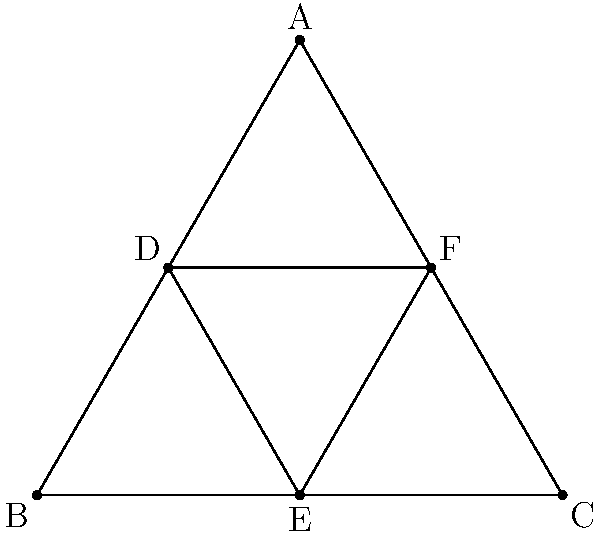In the Star of David shown above, all sides of both triangles are equal. If the angle at vertex A is 60°, calculate the measure of angle ADF. How might this angle's significance in religious symbolism influence your portrayal of divine wisdom in a theatrical script? Let's approach this step-by-step:

1) First, we recognize that the outer triangle ABC is equilateral, as all its sides are equal and the angle at A is given as 60°.

2) In an equilateral triangle, all angles are equal and measure 60°. So, $\angle BAC = \angle ABC = \angle BCA = 60°$.

3) The inner triangle DEF is formed by connecting the midpoints of the sides of the outer triangle. This creates four congruent triangles within ABC.

4) Focus on triangle ADF:
   - AD is half of AB
   - AF is half of AC
   - $\angle BAC = 60°$

5) Therefore, triangle ADF is similar to triangle ABC, but half its size.

6) Since triangle ABC has all 60° angles, triangle ADF must also have all 60° angles.

7) Thus, $\angle ADF = 60°$.

In a theatrical context, this 60° angle could symbolize balance, harmony, or the interconnectedness of different aspects of divinity. The consistency of this angle throughout the Star of David might represent the omnipresence of divine wisdom or the idea that truth can be found in multiple perspectives.
Answer: 60° 